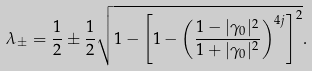Convert formula to latex. <formula><loc_0><loc_0><loc_500><loc_500>\lambda _ { \pm } = \frac { 1 } { 2 } \pm \frac { 1 } { 2 } \sqrt { 1 - \left [ 1 - \left ( \frac { 1 - | \gamma _ { 0 } | ^ { 2 } } { 1 + | \gamma _ { 0 } | ^ { 2 } } \right ) ^ { 4 j } \right ] ^ { 2 } } .</formula> 